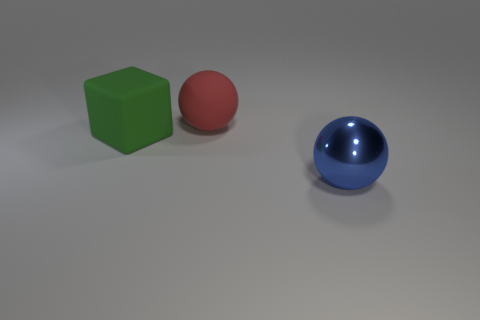There is a thing that is behind the large blue shiny sphere and right of the big rubber block; what is its size?
Give a very brief answer. Large. What is the shape of the large object that is both in front of the big red object and to the left of the metallic ball?
Give a very brief answer. Cube. Is there a sphere that is left of the large sphere that is to the left of the big sphere in front of the red sphere?
Ensure brevity in your answer.  No. How many objects are either spheres that are in front of the large rubber ball or things that are left of the big blue object?
Your answer should be very brief. 3. Does the sphere that is in front of the large red rubber sphere have the same material as the large green block?
Ensure brevity in your answer.  No. There is a large thing that is both behind the metallic sphere and in front of the large red object; what is its material?
Your answer should be very brief. Rubber. What is the color of the big thing to the left of the large ball that is to the left of the blue shiny object?
Keep it short and to the point. Green. What material is the big red object that is the same shape as the blue object?
Your response must be concise. Rubber. What color is the big matte object that is behind the big object to the left of the sphere behind the metallic thing?
Give a very brief answer. Red. What number of things are blue rubber cylinders or green cubes?
Give a very brief answer. 1. 